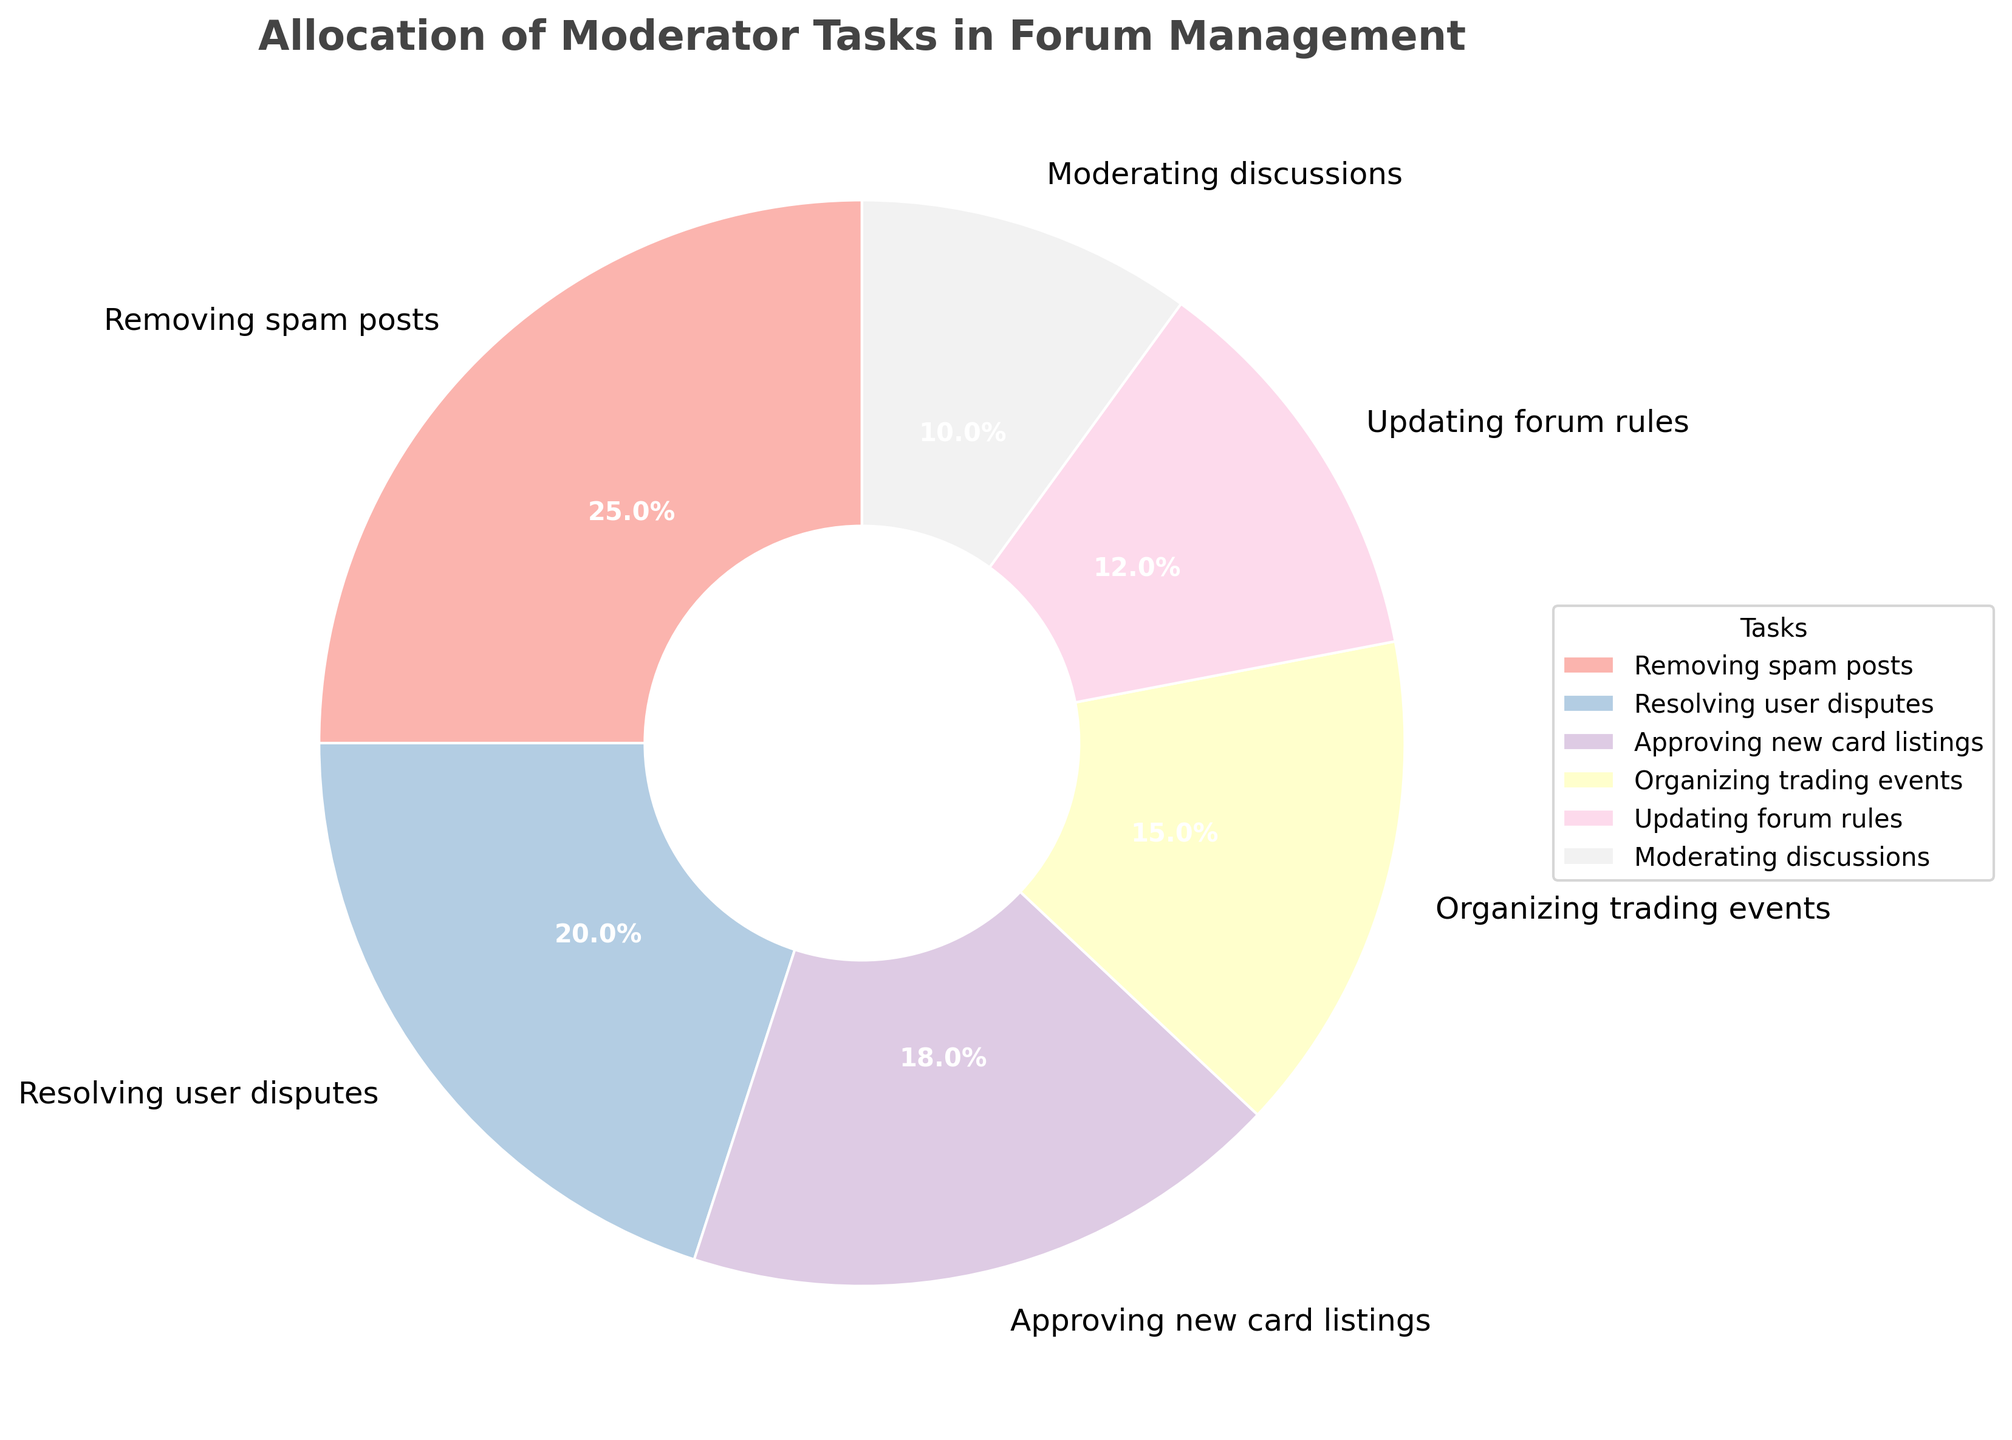What's the title of the plot? The title of the plot is usually displayed at the top of the figure. According to the data and code provided, the title is "Allocation of Moderator Tasks in Forum Management".
Answer: Allocation of Moderator Tasks in Forum Management Which task takes up the largest portion of the pie chart? Looking at the pie chart, the task that covers the largest slice of the pie will have the highest percentage. According to the data, "Removing spam posts" has 25%.
Answer: Removing spam posts What is the combined percentage of tasks related to user interactions (Resolving user disputes and Moderating discussions)? Resolving user disputes is 20% and Moderating discussions is 10%. Adding these two percentages gives 20% + 10% = 30%.
Answer: 30% Which task has the smallest allocation and what is its percentage? The smallest slice in the pie chart corresponds to the task with the lowest percentage. According to the data, "Moderating discussions" has 10%, which is the smallest.
Answer: Moderating discussions, 10% How much more percentage is allocated to "Organizing trading events" than "Moderating discussions"? "Organizing trading events" is 15% and "Moderating discussions" is 10%. Subtracting these two percentages gives 15% - 10% = 5%.
Answer: 5% Are there any tasks with an equal percentage allocation to any other task? By reviewing the percentages allocated to each task, we can determine if any are equal. In this case, no tasks share the same percentage.
Answer: No What is the sum of the percentages for the tasks "Approving new card listings" and "Updating forum rules"? "Approving new card listings" is 18% and "Updating forum rules" is 12%. Adding these gives 18% + 12% = 30%.
Answer: 30% What is the difference in percentage allocation between the task "Removing spam posts" and the task "Approving new card listings"? "Removing spam posts" is 25% and "Approving new card listings" is 18%. Subtracting these percentages gives 25% - 18% = 7%.
Answer: 7% If the percentages are represented in a pie chart, how many tasks are depicted? Each task is represented by a slice in the pie chart. Counting the unique tasks from the data, there are 6 tasks: Removing spam posts, Resolving user disputes, Approving new card listings, Organizing trading events, Updating forum rules, Moderating discussions.
Answer: 6 tasks What percentage of moderator tasks fall under event-related responsibilities (Approving new card listings and Organizing trading events)? Combining percentages for event-related tasks: Approving new card listings (18%) and Organizing trading events (15%). Adding these gives 18% + 15% = 33%.
Answer: 33% 